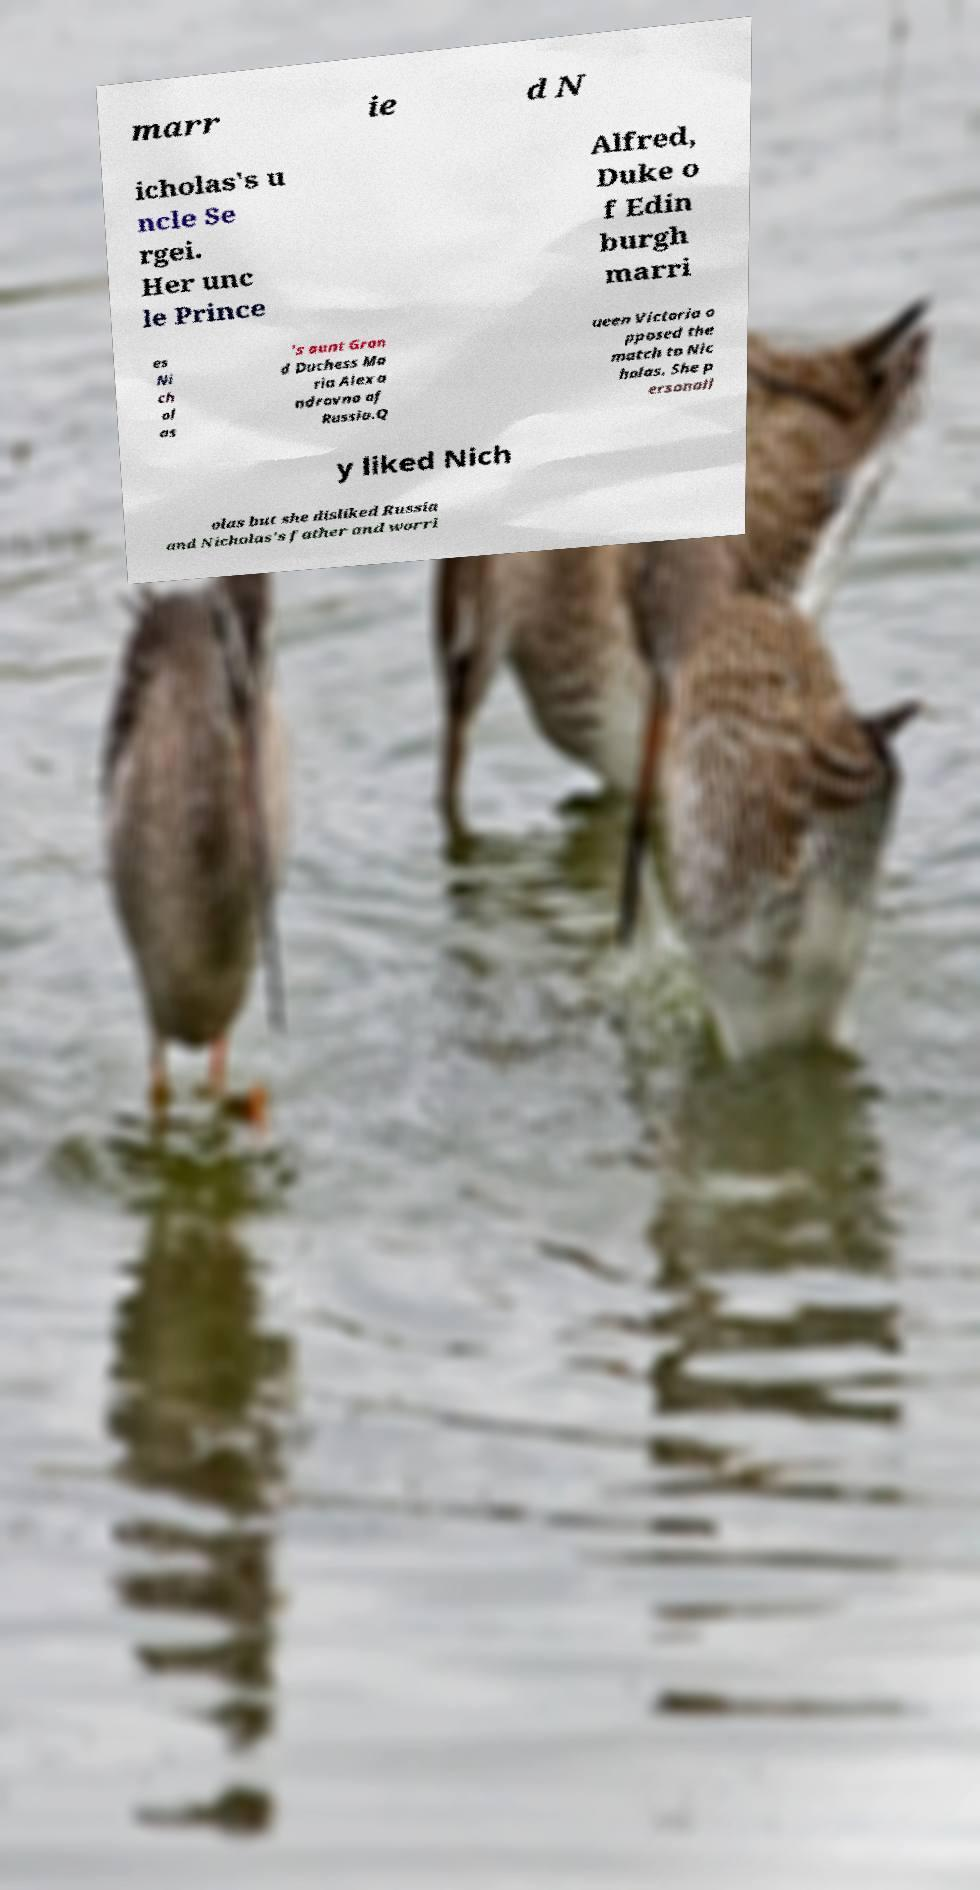Could you extract and type out the text from this image? marr ie d N icholas's u ncle Se rgei. Her unc le Prince Alfred, Duke o f Edin burgh marri es Ni ch ol as 's aunt Gran d Duchess Ma ria Alexa ndrovna of Russia.Q ueen Victoria o pposed the match to Nic holas. She p ersonall y liked Nich olas but she disliked Russia and Nicholas's father and worri 